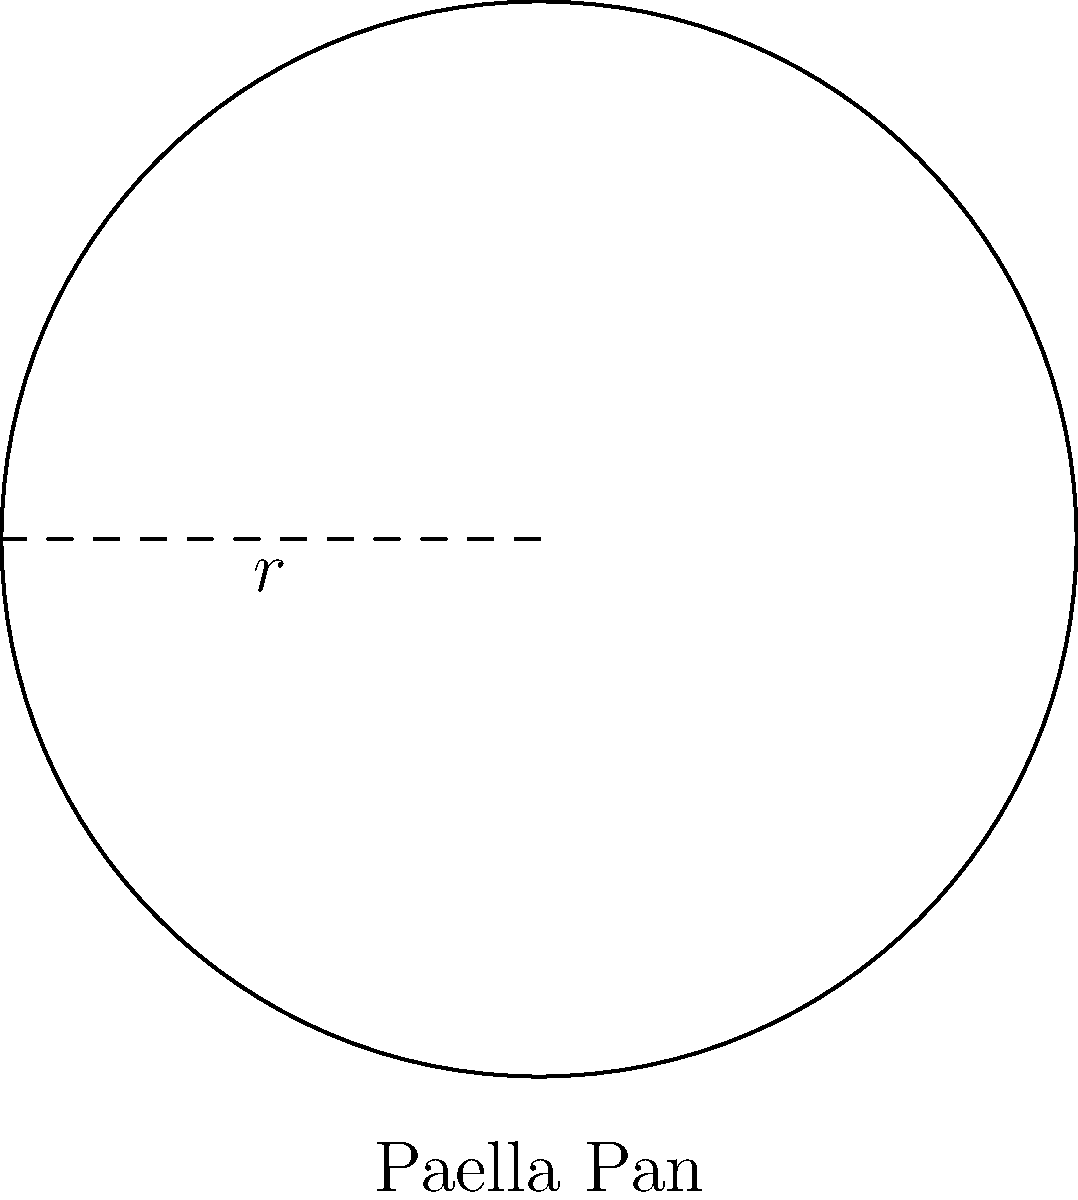As a tennis coach, you often enjoy cooking paella for your team after practice. You have a circular paella pan with a diameter of 60 cm. What is the perimeter of the pan's base? To find the perimeter of the circular paella pan base, we need to use the formula for the circumference of a circle:

1. The formula for the circumference of a circle is $C = 2\pi r$, where $r$ is the radius.

2. We are given the diameter, which is 60 cm. The radius is half of the diameter:
   $r = 60 \text{ cm} \div 2 = 30 \text{ cm}$

3. Now, let's substitute the radius into the circumference formula:
   $C = 2\pi r = 2\pi(30 \text{ cm})$

4. Simplify:
   $C = 60\pi \text{ cm}$

5. If we need to give a decimal approximation:
   $C \approx 60 \times 3.14159 \text{ cm} \approx 188.50 \text{ cm}$

Therefore, the perimeter of the paella pan's base is $60\pi$ cm or approximately 188.50 cm.
Answer: $60\pi \text{ cm}$ (or approximately 188.50 cm) 